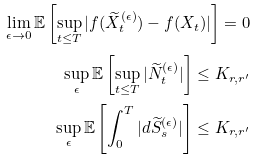Convert formula to latex. <formula><loc_0><loc_0><loc_500><loc_500>\lim _ { \epsilon \rightarrow 0 } \mathbb { E } \left [ \sup _ { t \leq T } | f ( \widetilde { X } _ { t } ^ { ( \epsilon ) } ) - f ( X _ { t } ) | \right ] = 0 \\ \sup _ { \epsilon } \mathbb { E } \left [ \sup _ { t \leq T } | \widetilde { N } _ { t } ^ { ( \epsilon ) } | \right ] \leq K _ { r , r ^ { \prime } } \\ \sup _ { \epsilon } \mathbb { E } \left [ \int _ { 0 } ^ { T } | d \widetilde { S } _ { s } ^ { ( \epsilon ) } | \right ] \leq K _ { r , r ^ { \prime } }</formula> 